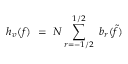Convert formula to latex. <formula><loc_0><loc_0><loc_500><loc_500>h _ { v } ( f ) \ = \ N \sum _ { r = - 1 / 2 } ^ { 1 / 2 } \ b _ { r } ( \tilde { f } )</formula> 